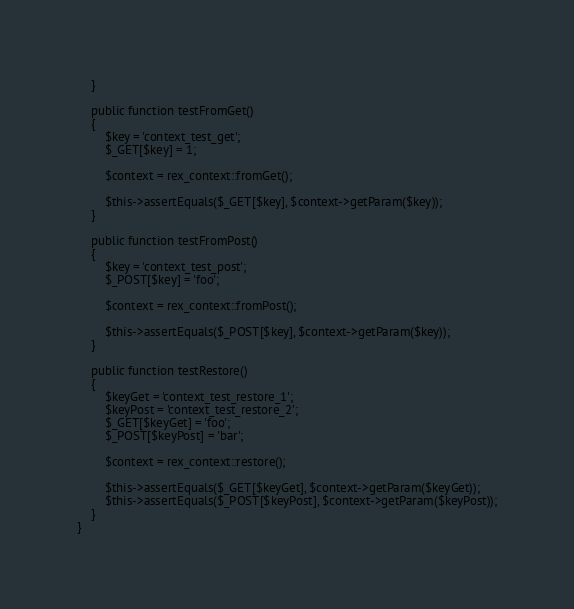<code> <loc_0><loc_0><loc_500><loc_500><_PHP_>    }

    public function testFromGet()
    {
        $key = 'context_test_get';
        $_GET[$key] = 1;

        $context = rex_context::fromGet();

        $this->assertEquals($_GET[$key], $context->getParam($key));
    }

    public function testFromPost()
    {
        $key = 'context_test_post';
        $_POST[$key] = 'foo';

        $context = rex_context::fromPost();

        $this->assertEquals($_POST[$key], $context->getParam($key));
    }

    public function testRestore()
    {
        $keyGet = 'context_test_restore_1';
        $keyPost = 'context_test_restore_2';
        $_GET[$keyGet] = 'foo';
        $_POST[$keyPost] = 'bar';

        $context = rex_context::restore();

        $this->assertEquals($_GET[$keyGet], $context->getParam($keyGet));
        $this->assertEquals($_POST[$keyPost], $context->getParam($keyPost));
    }
}
</code> 